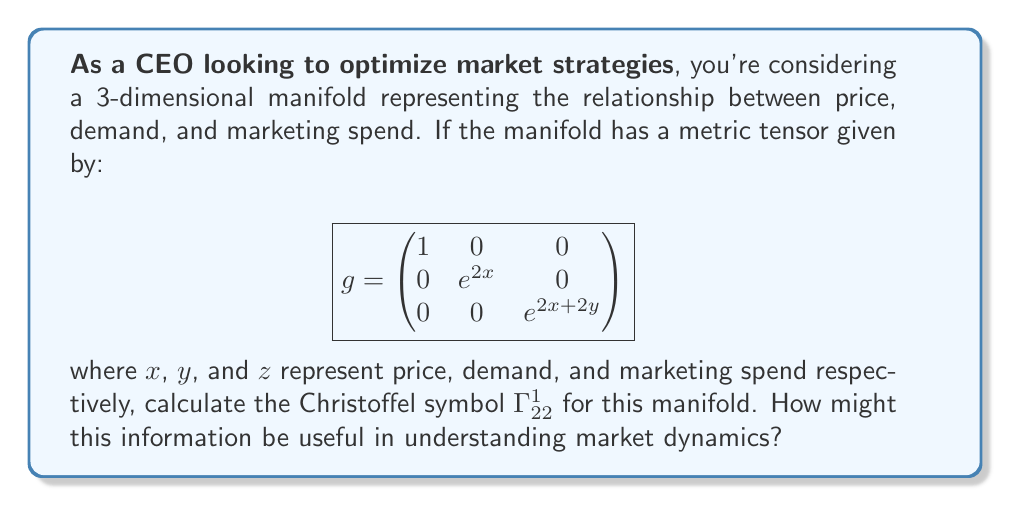Help me with this question. To calculate the Christoffel symbol $\Gamma^1_{22}$, we'll use the formula:

$$\Gamma^k_{ij} = \frac{1}{2}g^{kl}\left(\frac{\partial g_{li}}{\partial x^j} + \frac{\partial g_{lj}}{\partial x^i} - \frac{\partial g_{ij}}{\partial x^l}\right)$$

Step 1: Identify the relevant components of the metric tensor and its inverse.
$g_{22} = e^{2x}$
$g^{11} = 1$ (inverse of $g_{11}$)

Step 2: Calculate the partial derivatives.
$\frac{\partial g_{21}}{\partial x^2} = 0$
$\frac{\partial g_{22}}{\partial x^1} = 2e^{2x}$
$\frac{\partial g_{12}}{\partial x^1} = 0$

Step 3: Apply the formula.
$$\begin{align}
\Gamma^1_{22} &= \frac{1}{2}g^{11}\left(\frac{\partial g_{12}}{\partial x^2} + \frac{\partial g_{12}}{\partial x^2} - \frac{\partial g_{22}}{\partial x^1}\right) \\
&= \frac{1}{2}(1)(0 + 0 - 2e^{2x}) \\
&= -e^{2x}
\end{align}$$

This Christoffel symbol represents the curvature of the manifold in the direction of demand with respect to price. In business terms, it indicates how changes in demand affect the relationship between price and marketing spend. A negative value suggests that as demand increases, the rate of change in price with respect to marketing spend decreases exponentially.

Understanding this relationship can help in optimizing pricing strategies and marketing budget allocation. For instance, it implies that as demand grows, the effectiveness of increased marketing spend on price adjustments diminishes, suggesting a need for more nuanced pricing strategies in high-demand scenarios.
Answer: $\Gamma^1_{22} = -e^{2x}$ 